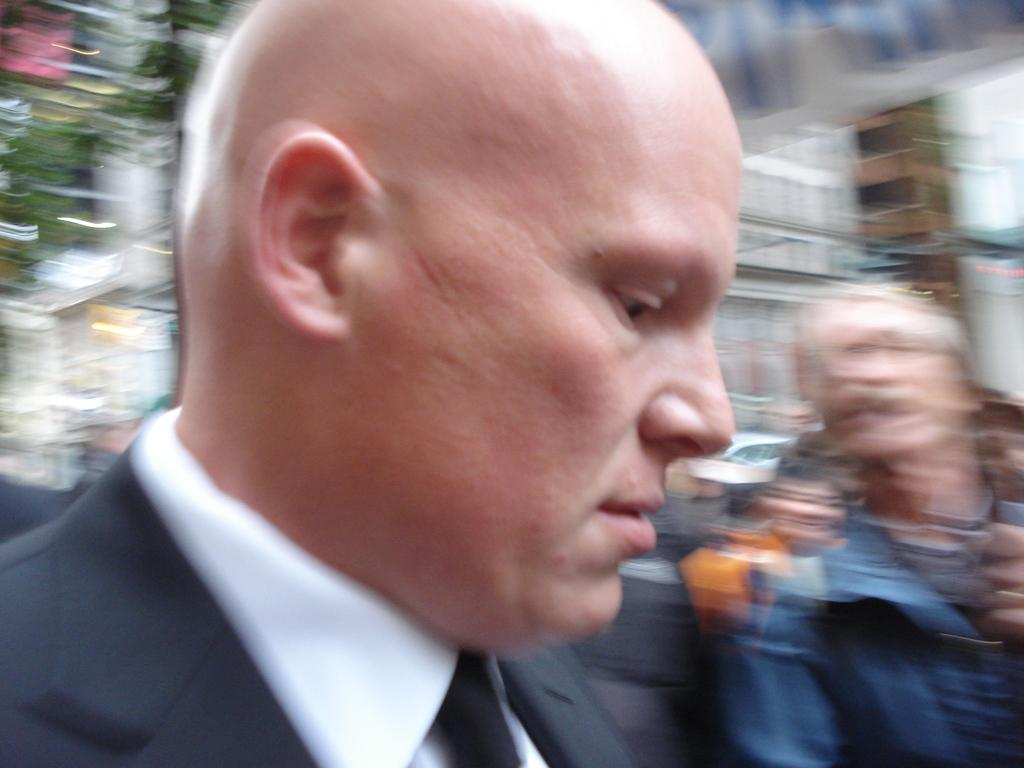What is the main subject of the image? The main subject of the image is groups of people. Can you describe the background of the image? The background of the image is blurred. How many ears can be seen on the people in the image? There is no way to determine the number of ears visible in the image, as the people are not individually identifiable due to the blurred background. 